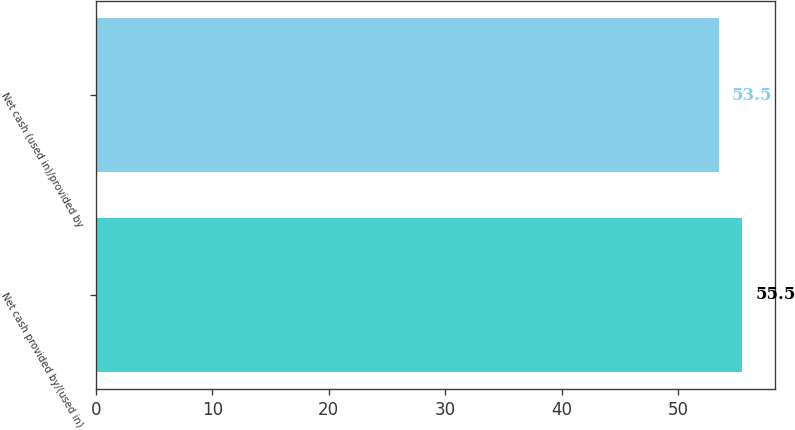Convert chart to OTSL. <chart><loc_0><loc_0><loc_500><loc_500><bar_chart><fcel>Net cash provided by/(used in)<fcel>Net cash (used in)/provided by<nl><fcel>55.5<fcel>53.5<nl></chart> 